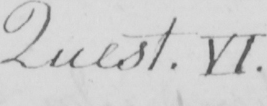What does this handwritten line say? Quest . VI . 